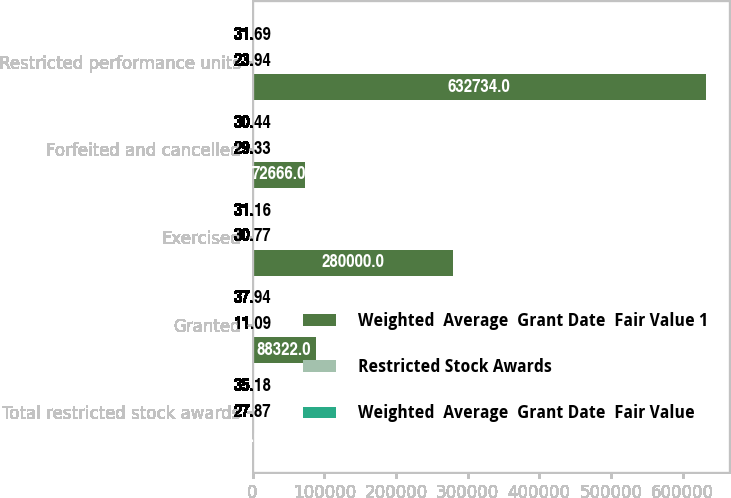Convert chart. <chart><loc_0><loc_0><loc_500><loc_500><stacked_bar_chart><ecel><fcel>Total restricted stock awards<fcel>Granted<fcel>Exercised<fcel>Forfeited and cancelled<fcel>Restricted performance units<nl><fcel>Weighted  Average  Grant Date  Fair Value 1<fcel>31.02<fcel>88322<fcel>280000<fcel>72666<fcel>632734<nl><fcel>Restricted Stock Awards<fcel>27.87<fcel>11.09<fcel>30.77<fcel>29.33<fcel>23.94<nl><fcel>Weighted  Average  Grant Date  Fair Value<fcel>35.18<fcel>37.94<fcel>31.16<fcel>30.44<fcel>31.69<nl></chart> 